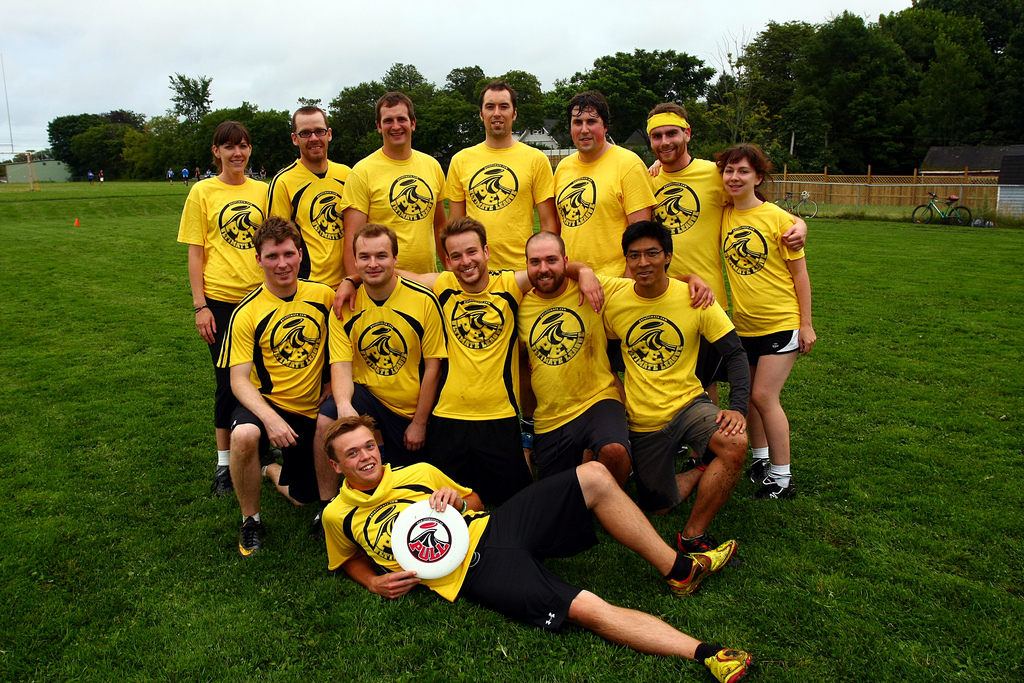What sport might this team be playing? Considering the team uniforms and the open field in the background, they might be playing ultimate frisbee, which is often played in similar settings. The disc held by the person lying down supports this guess. 